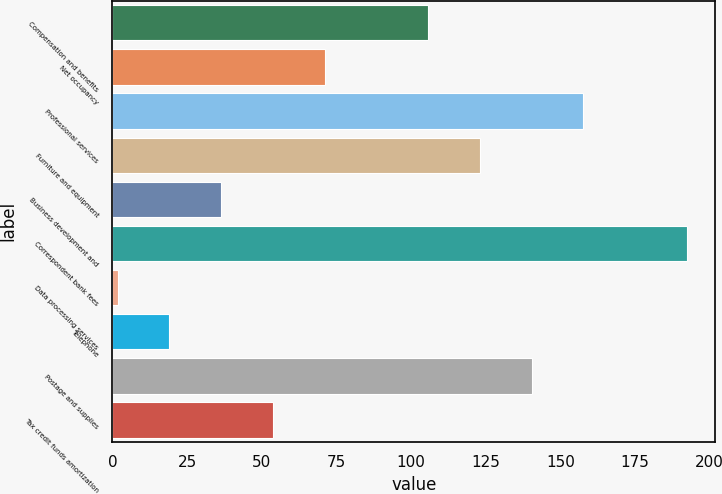Convert chart to OTSL. <chart><loc_0><loc_0><loc_500><loc_500><bar_chart><fcel>Compensation and benefits<fcel>Net occupancy<fcel>Professional services<fcel>Furniture and equipment<fcel>Business development and<fcel>Correspondent bank fees<fcel>Data processing services<fcel>Telephone<fcel>Postage and supplies<fcel>Tax credit funds amortization<nl><fcel>105.68<fcel>71.02<fcel>157.67<fcel>123.01<fcel>36.36<fcel>192.33<fcel>1.7<fcel>19.03<fcel>140.34<fcel>53.69<nl></chart> 